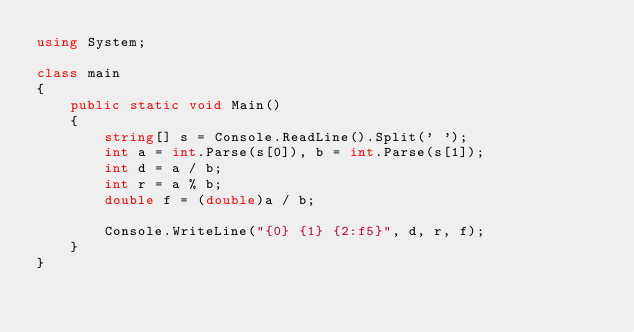<code> <loc_0><loc_0><loc_500><loc_500><_C#_>using System;

class main
{
    public static void Main()
    {
        string[] s = Console.ReadLine().Split(' ');
        int a = int.Parse(s[0]), b = int.Parse(s[1]);
        int d = a / b;
        int r = a % b;
        double f = (double)a / b;

        Console.WriteLine("{0} {1} {2:f5}", d, r, f);
    }
}</code> 